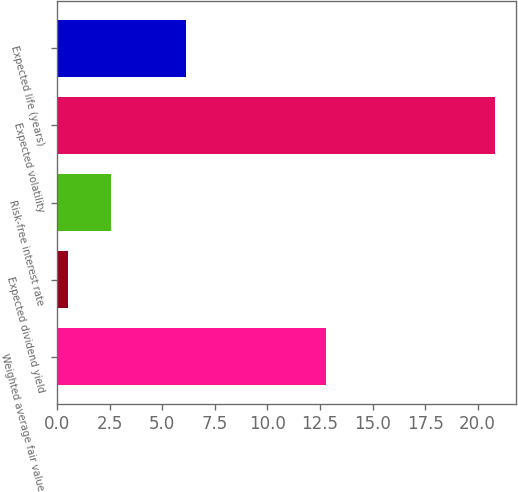Convert chart. <chart><loc_0><loc_0><loc_500><loc_500><bar_chart><fcel>Weighted average fair value<fcel>Expected dividend yield<fcel>Risk-free interest rate<fcel>Expected volatility<fcel>Expected life (years)<nl><fcel>12.78<fcel>0.52<fcel>2.55<fcel>20.8<fcel>6.14<nl></chart> 